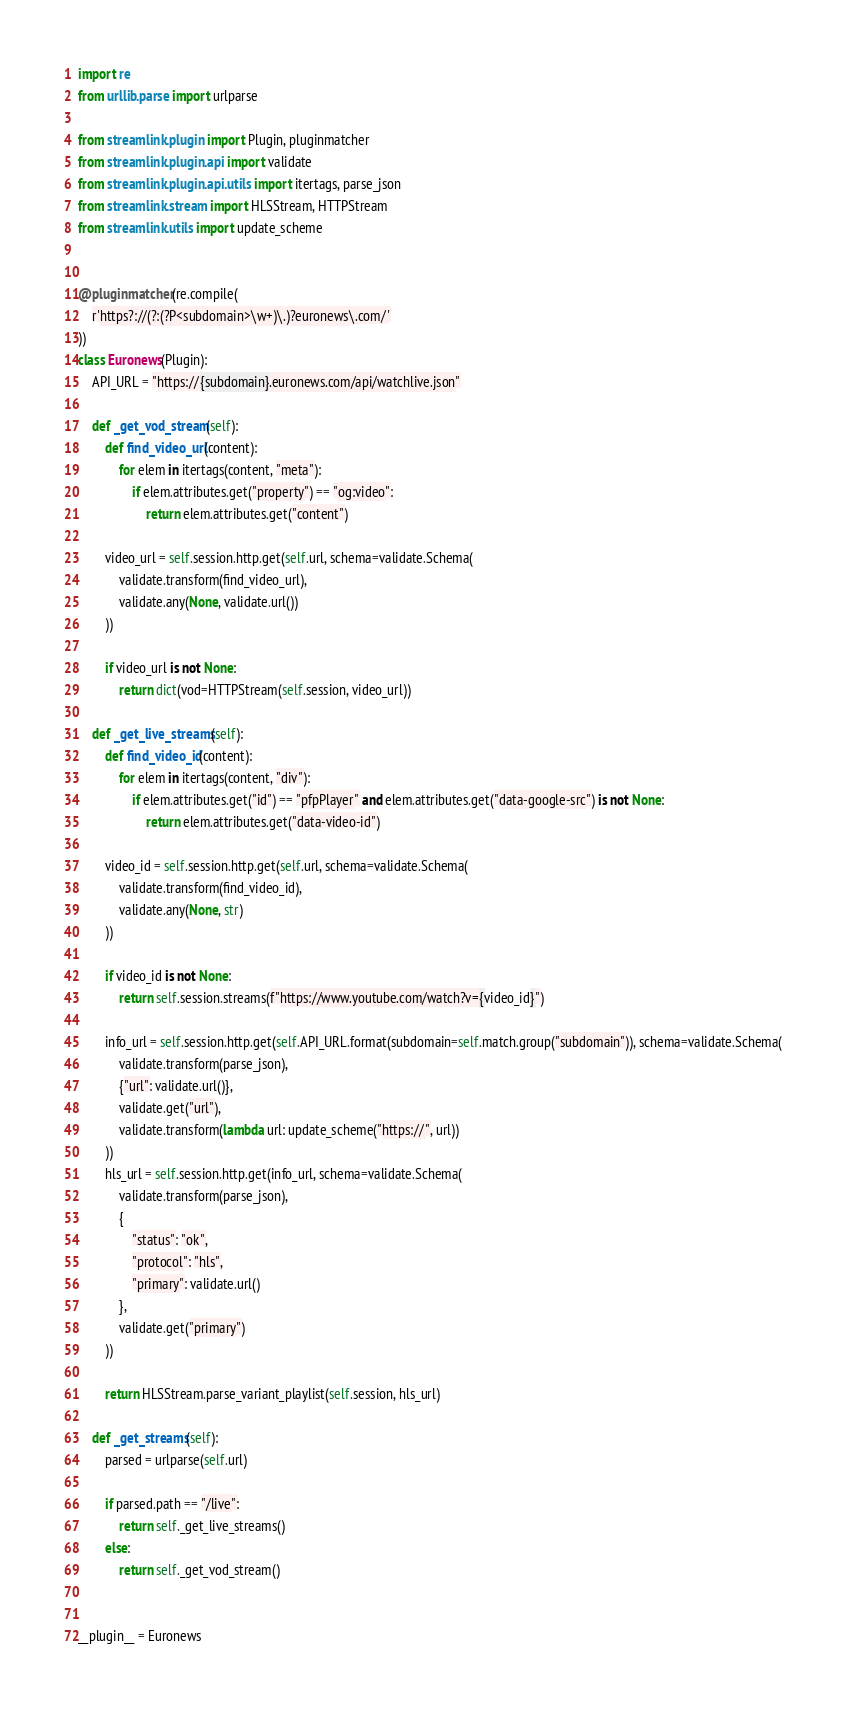<code> <loc_0><loc_0><loc_500><loc_500><_Python_>import re
from urllib.parse import urlparse

from streamlink.plugin import Plugin, pluginmatcher
from streamlink.plugin.api import validate
from streamlink.plugin.api.utils import itertags, parse_json
from streamlink.stream import HLSStream, HTTPStream
from streamlink.utils import update_scheme


@pluginmatcher(re.compile(
    r'https?://(?:(?P<subdomain>\w+)\.)?euronews\.com/'
))
class Euronews(Plugin):
    API_URL = "https://{subdomain}.euronews.com/api/watchlive.json"

    def _get_vod_stream(self):
        def find_video_url(content):
            for elem in itertags(content, "meta"):
                if elem.attributes.get("property") == "og:video":
                    return elem.attributes.get("content")

        video_url = self.session.http.get(self.url, schema=validate.Schema(
            validate.transform(find_video_url),
            validate.any(None, validate.url())
        ))

        if video_url is not None:
            return dict(vod=HTTPStream(self.session, video_url))

    def _get_live_streams(self):
        def find_video_id(content):
            for elem in itertags(content, "div"):
                if elem.attributes.get("id") == "pfpPlayer" and elem.attributes.get("data-google-src") is not None:
                    return elem.attributes.get("data-video-id")

        video_id = self.session.http.get(self.url, schema=validate.Schema(
            validate.transform(find_video_id),
            validate.any(None, str)
        ))

        if video_id is not None:
            return self.session.streams(f"https://www.youtube.com/watch?v={video_id}")

        info_url = self.session.http.get(self.API_URL.format(subdomain=self.match.group("subdomain")), schema=validate.Schema(
            validate.transform(parse_json),
            {"url": validate.url()},
            validate.get("url"),
            validate.transform(lambda url: update_scheme("https://", url))
        ))
        hls_url = self.session.http.get(info_url, schema=validate.Schema(
            validate.transform(parse_json),
            {
                "status": "ok",
                "protocol": "hls",
                "primary": validate.url()
            },
            validate.get("primary")
        ))

        return HLSStream.parse_variant_playlist(self.session, hls_url)

    def _get_streams(self):
        parsed = urlparse(self.url)

        if parsed.path == "/live":
            return self._get_live_streams()
        else:
            return self._get_vod_stream()


__plugin__ = Euronews
</code> 